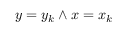<formula> <loc_0><loc_0><loc_500><loc_500>y = y _ { k } \land x = x _ { k }</formula> 